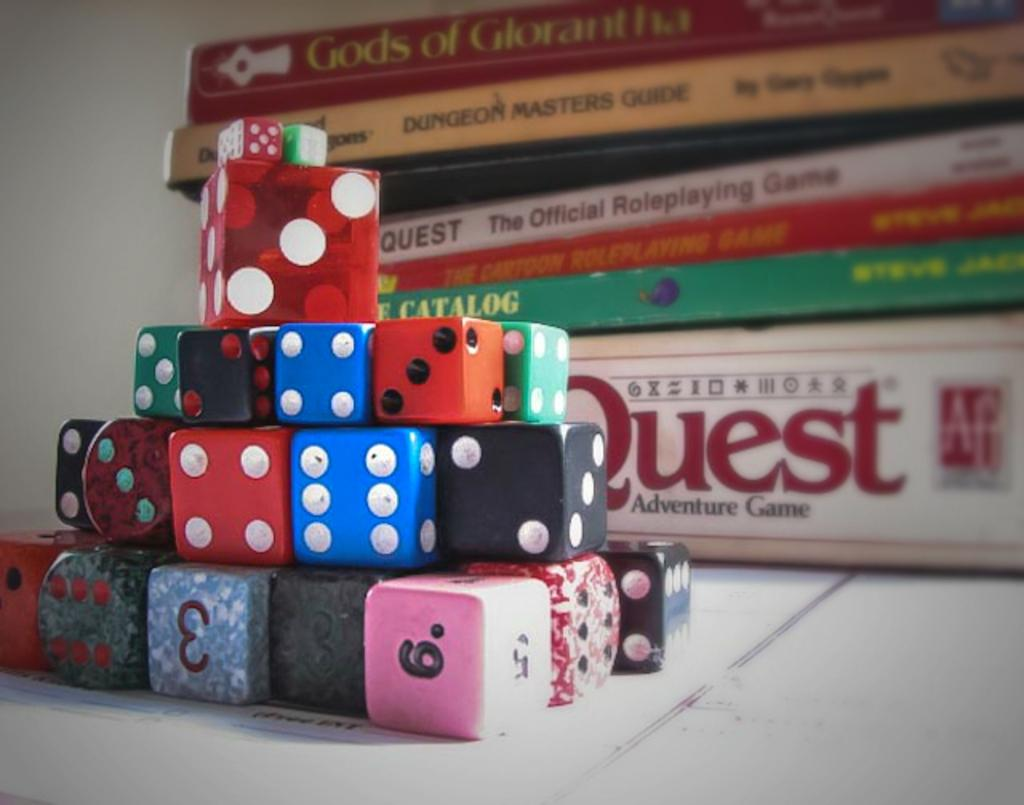<image>
Give a short and clear explanation of the subsequent image. A pile of colored die are in front of a stack of board games including Quest. 